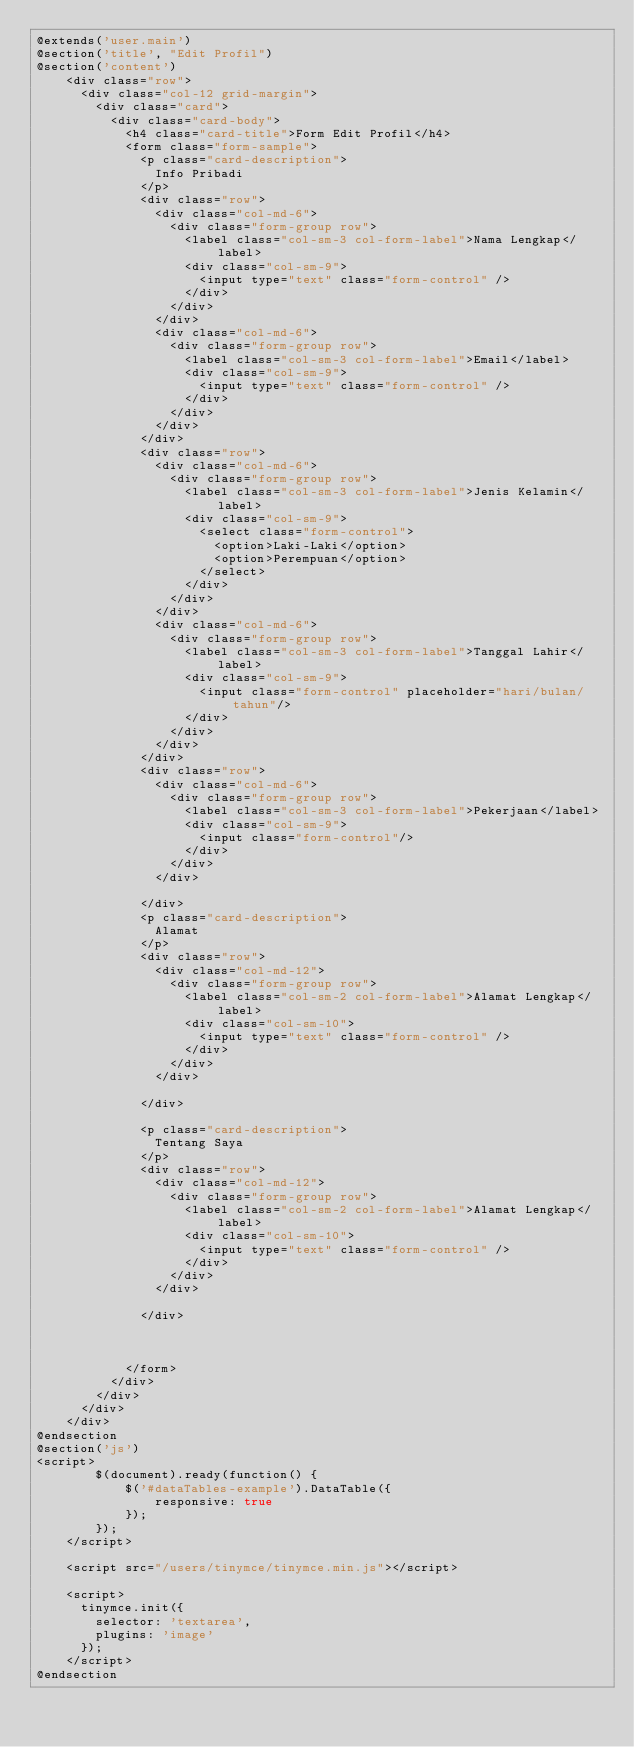Convert code to text. <code><loc_0><loc_0><loc_500><loc_500><_PHP_>@extends('user.main')
@section('title', "Edit Profil")
@section('content')
    <div class="row">
      <div class="col-12 grid-margin">
        <div class="card">
          <div class="card-body">
            <h4 class="card-title">Form Edit Profil</h4>
            <form class="form-sample">
              <p class="card-description">
                Info Pribadi
              </p>
              <div class="row">
                <div class="col-md-6">
                  <div class="form-group row">
                    <label class="col-sm-3 col-form-label">Nama Lengkap</label>
                    <div class="col-sm-9">
                      <input type="text" class="form-control" />
                    </div>
                  </div>
                </div>
                <div class="col-md-6">
                  <div class="form-group row">
                    <label class="col-sm-3 col-form-label">Email</label>
                    <div class="col-sm-9">
                      <input type="text" class="form-control" />
                    </div>
                  </div>
                </div>
              </div>
              <div class="row">
                <div class="col-md-6">
                  <div class="form-group row">
                    <label class="col-sm-3 col-form-label">Jenis Kelamin</label>
                    <div class="col-sm-9">
                      <select class="form-control">
                        <option>Laki-Laki</option>
                        <option>Perempuan</option>
                      </select>
                    </div>
                  </div>
                </div>
                <div class="col-md-6">
                  <div class="form-group row">
                    <label class="col-sm-3 col-form-label">Tanggal Lahir</label>
                    <div class="col-sm-9">
                      <input class="form-control" placeholder="hari/bulan/tahun"/>
                    </div>
                  </div>
                </div>
              </div>
              <div class="row">
                <div class="col-md-6">
                  <div class="form-group row">
                    <label class="col-sm-3 col-form-label">Pekerjaan</label>
                    <div class="col-sm-9">
                      <input class="form-control"/>
                    </div>
                  </div>
                </div>
                
              </div>
              <p class="card-description">
                Alamat
              </p>
              <div class="row">
                <div class="col-md-12">
                  <div class="form-group row">
                    <label class="col-sm-2 col-form-label">Alamat Lengkap</label>
                    <div class="col-sm-10">
                      <input type="text" class="form-control" />
                    </div>
                  </div>
                </div>
                
              </div>

              <p class="card-description">
                Tentang Saya
              </p>
              <div class="row">
                <div class="col-md-12">
                  <div class="form-group row">
                    <label class="col-sm-2 col-form-label">Alamat Lengkap</label>
                    <div class="col-sm-10">
                      <input type="text" class="form-control" />
                    </div>
                  </div>
                </div>
                
              </div>
              
                
              
            </form>
          </div>
        </div>
      </div>
    </div>
@endsection
@section('js')
<script>
        $(document).ready(function() {
            $('#dataTables-example').DataTable({
                responsive: true
            });
        });
    </script>

    <script src="/users/tinymce/tinymce.min.js"></script>

    <script>
      tinymce.init({
        selector: 'textarea',
        plugins: 'image'
      });
    </script>
@endsection</code> 